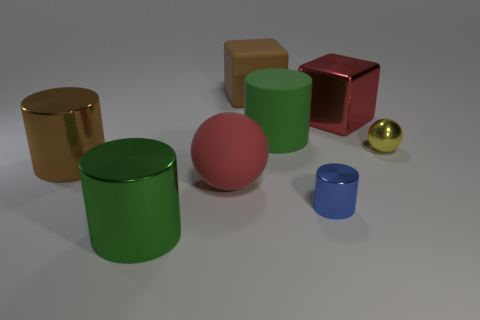Subtract all small blue cylinders. How many cylinders are left? 3 Subtract all green blocks. How many green cylinders are left? 2 Subtract all brown cylinders. How many cylinders are left? 3 Add 2 small blue metal cubes. How many objects exist? 10 Subtract 1 spheres. How many spheres are left? 1 Subtract all balls. How many objects are left? 6 Subtract all purple cylinders. Subtract all brown spheres. How many cylinders are left? 4 Subtract all big objects. Subtract all red rubber objects. How many objects are left? 1 Add 7 yellow shiny things. How many yellow shiny things are left? 8 Add 2 big cyan metallic blocks. How many big cyan metallic blocks exist? 2 